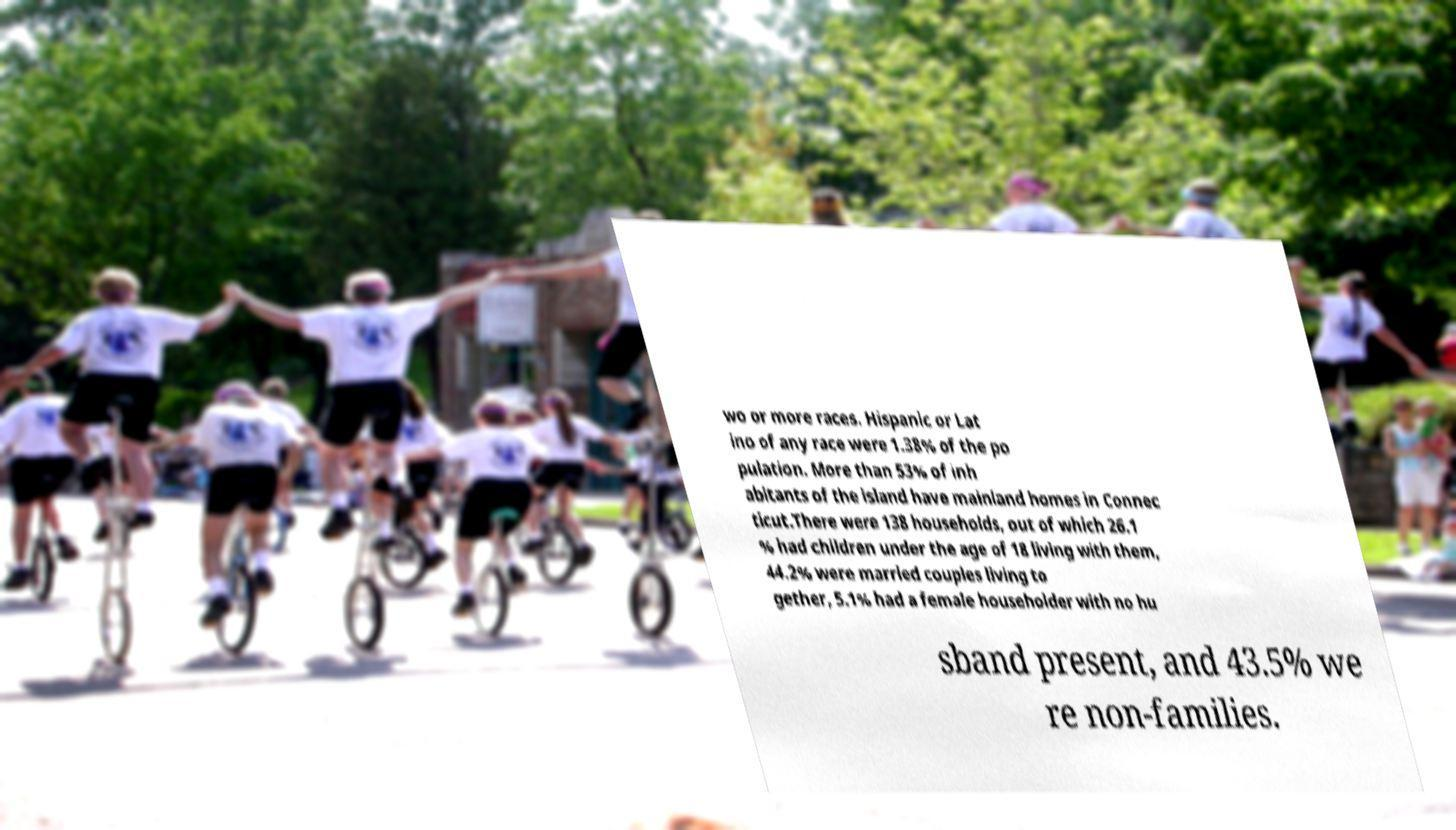For documentation purposes, I need the text within this image transcribed. Could you provide that? wo or more races. Hispanic or Lat ino of any race were 1.38% of the po pulation. More than 53% of inh abitants of the island have mainland homes in Connec ticut.There were 138 households, out of which 26.1 % had children under the age of 18 living with them, 44.2% were married couples living to gether, 5.1% had a female householder with no hu sband present, and 43.5% we re non-families. 